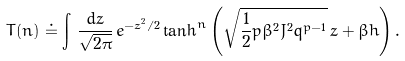Convert formula to latex. <formula><loc_0><loc_0><loc_500><loc_500>T ( n ) \doteq \int \, \frac { d z } { \sqrt { 2 \pi } } \, e ^ { - z ^ { 2 } / 2 } \tanh ^ { n } \left ( \sqrt { \frac { 1 } { 2 } p \beta ^ { 2 } J ^ { 2 } q ^ { p - 1 } } \, z + \beta h \right ) .</formula> 